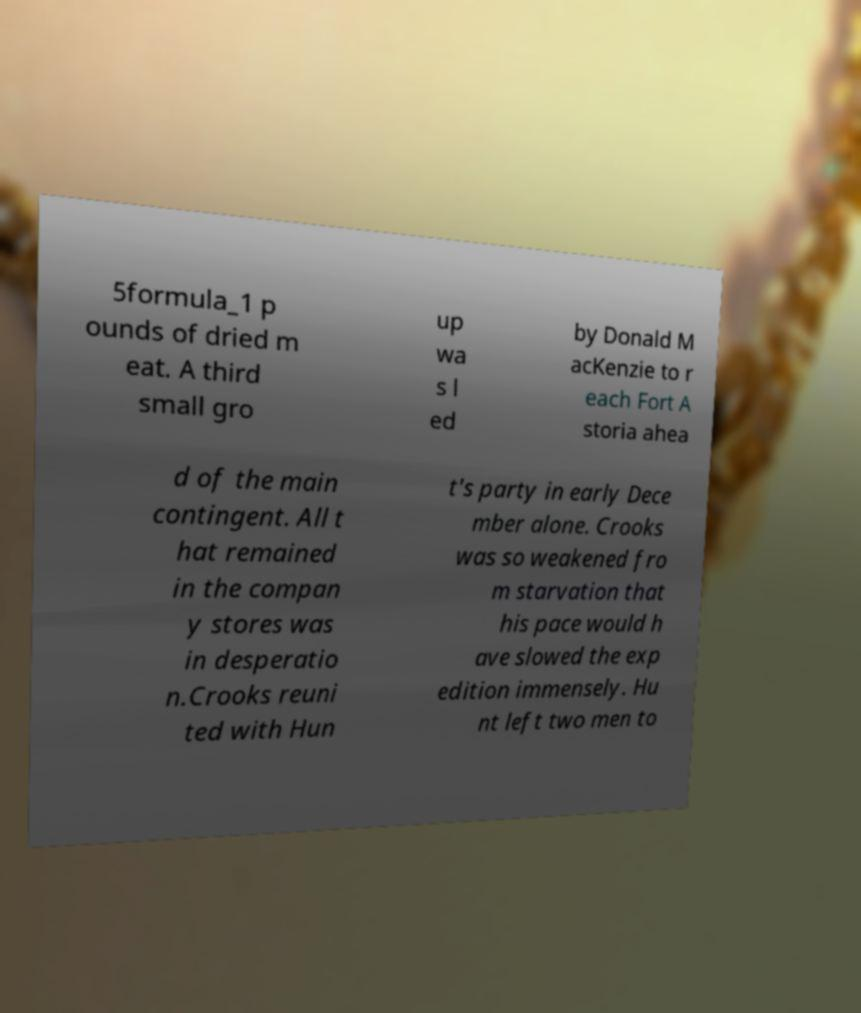Could you extract and type out the text from this image? 5formula_1 p ounds of dried m eat. A third small gro up wa s l ed by Donald M acKenzie to r each Fort A storia ahea d of the main contingent. All t hat remained in the compan y stores was in desperatio n.Crooks reuni ted with Hun t's party in early Dece mber alone. Crooks was so weakened fro m starvation that his pace would h ave slowed the exp edition immensely. Hu nt left two men to 